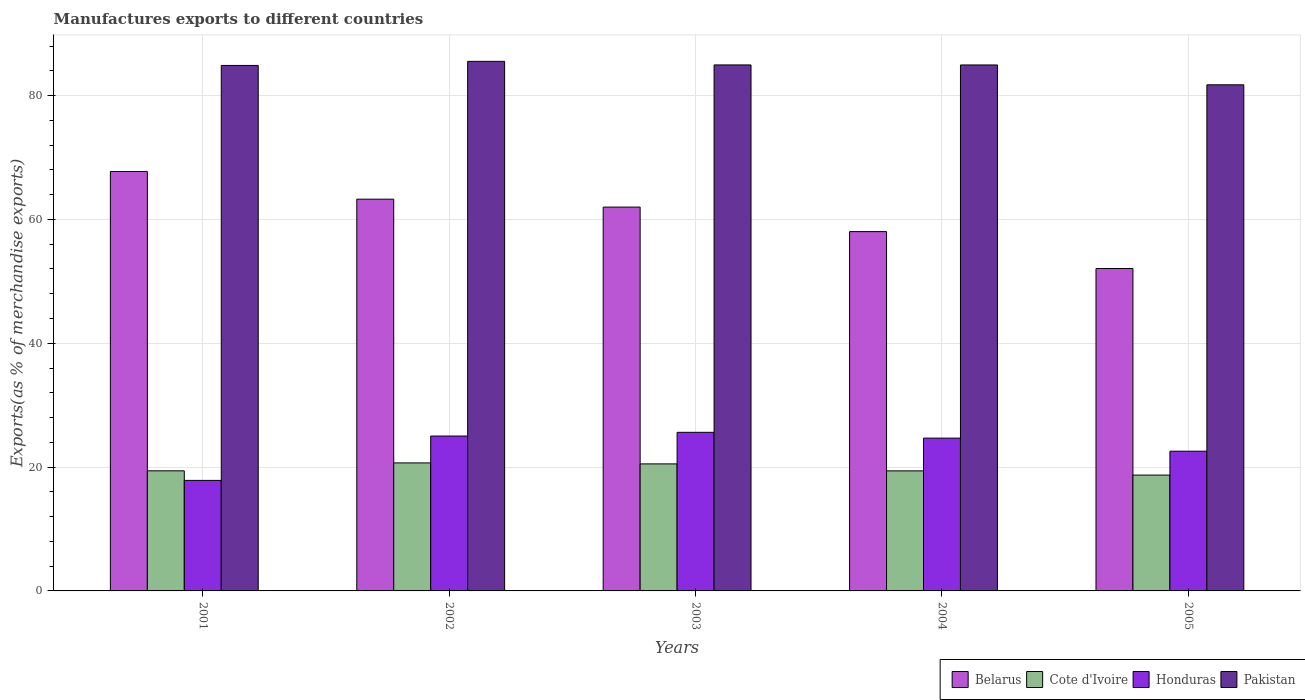Are the number of bars per tick equal to the number of legend labels?
Ensure brevity in your answer.  Yes. Are the number of bars on each tick of the X-axis equal?
Offer a terse response. Yes. How many bars are there on the 1st tick from the left?
Give a very brief answer. 4. How many bars are there on the 3rd tick from the right?
Keep it short and to the point. 4. What is the label of the 2nd group of bars from the left?
Your answer should be compact. 2002. In how many cases, is the number of bars for a given year not equal to the number of legend labels?
Your answer should be compact. 0. What is the percentage of exports to different countries in Cote d'Ivoire in 2004?
Give a very brief answer. 19.39. Across all years, what is the maximum percentage of exports to different countries in Pakistan?
Your answer should be compact. 85.54. Across all years, what is the minimum percentage of exports to different countries in Belarus?
Your response must be concise. 52.08. In which year was the percentage of exports to different countries in Cote d'Ivoire minimum?
Ensure brevity in your answer.  2005. What is the total percentage of exports to different countries in Cote d'Ivoire in the graph?
Your response must be concise. 98.69. What is the difference between the percentage of exports to different countries in Belarus in 2004 and that in 2005?
Your response must be concise. 5.96. What is the difference between the percentage of exports to different countries in Cote d'Ivoire in 2003 and the percentage of exports to different countries in Honduras in 2004?
Make the answer very short. -4.16. What is the average percentage of exports to different countries in Pakistan per year?
Your answer should be compact. 84.42. In the year 2005, what is the difference between the percentage of exports to different countries in Pakistan and percentage of exports to different countries in Belarus?
Your answer should be compact. 29.67. What is the ratio of the percentage of exports to different countries in Pakistan in 2002 to that in 2004?
Keep it short and to the point. 1.01. Is the percentage of exports to different countries in Pakistan in 2001 less than that in 2003?
Your answer should be compact. Yes. Is the difference between the percentage of exports to different countries in Pakistan in 2001 and 2004 greater than the difference between the percentage of exports to different countries in Belarus in 2001 and 2004?
Keep it short and to the point. No. What is the difference between the highest and the second highest percentage of exports to different countries in Belarus?
Provide a succinct answer. 4.47. What is the difference between the highest and the lowest percentage of exports to different countries in Pakistan?
Make the answer very short. 3.79. Is the sum of the percentage of exports to different countries in Belarus in 2001 and 2004 greater than the maximum percentage of exports to different countries in Pakistan across all years?
Ensure brevity in your answer.  Yes. Is it the case that in every year, the sum of the percentage of exports to different countries in Honduras and percentage of exports to different countries in Belarus is greater than the sum of percentage of exports to different countries in Cote d'Ivoire and percentage of exports to different countries in Pakistan?
Offer a very short reply. No. What does the 4th bar from the left in 2002 represents?
Provide a short and direct response. Pakistan. What does the 2nd bar from the right in 2001 represents?
Give a very brief answer. Honduras. How many bars are there?
Your answer should be compact. 20. Are all the bars in the graph horizontal?
Give a very brief answer. No. Where does the legend appear in the graph?
Give a very brief answer. Bottom right. How many legend labels are there?
Your answer should be very brief. 4. How are the legend labels stacked?
Offer a terse response. Horizontal. What is the title of the graph?
Provide a succinct answer. Manufactures exports to different countries. Does "Other small states" appear as one of the legend labels in the graph?
Give a very brief answer. No. What is the label or title of the Y-axis?
Give a very brief answer. Exports(as % of merchandise exports). What is the Exports(as % of merchandise exports) in Belarus in 2001?
Make the answer very short. 67.75. What is the Exports(as % of merchandise exports) of Cote d'Ivoire in 2001?
Offer a terse response. 19.4. What is the Exports(as % of merchandise exports) of Honduras in 2001?
Provide a short and direct response. 17.85. What is the Exports(as % of merchandise exports) in Pakistan in 2001?
Keep it short and to the point. 84.88. What is the Exports(as % of merchandise exports) of Belarus in 2002?
Provide a short and direct response. 63.28. What is the Exports(as % of merchandise exports) in Cote d'Ivoire in 2002?
Your response must be concise. 20.68. What is the Exports(as % of merchandise exports) in Honduras in 2002?
Offer a terse response. 25.02. What is the Exports(as % of merchandise exports) of Pakistan in 2002?
Ensure brevity in your answer.  85.54. What is the Exports(as % of merchandise exports) of Belarus in 2003?
Provide a succinct answer. 62. What is the Exports(as % of merchandise exports) of Cote d'Ivoire in 2003?
Offer a very short reply. 20.52. What is the Exports(as % of merchandise exports) of Honduras in 2003?
Provide a succinct answer. 25.62. What is the Exports(as % of merchandise exports) in Pakistan in 2003?
Your response must be concise. 84.96. What is the Exports(as % of merchandise exports) of Belarus in 2004?
Provide a succinct answer. 58.04. What is the Exports(as % of merchandise exports) in Cote d'Ivoire in 2004?
Keep it short and to the point. 19.39. What is the Exports(as % of merchandise exports) in Honduras in 2004?
Provide a short and direct response. 24.68. What is the Exports(as % of merchandise exports) of Pakistan in 2004?
Provide a succinct answer. 84.96. What is the Exports(as % of merchandise exports) of Belarus in 2005?
Ensure brevity in your answer.  52.08. What is the Exports(as % of merchandise exports) in Cote d'Ivoire in 2005?
Provide a succinct answer. 18.71. What is the Exports(as % of merchandise exports) of Honduras in 2005?
Offer a terse response. 22.57. What is the Exports(as % of merchandise exports) in Pakistan in 2005?
Provide a succinct answer. 81.75. Across all years, what is the maximum Exports(as % of merchandise exports) of Belarus?
Ensure brevity in your answer.  67.75. Across all years, what is the maximum Exports(as % of merchandise exports) in Cote d'Ivoire?
Your response must be concise. 20.68. Across all years, what is the maximum Exports(as % of merchandise exports) in Honduras?
Ensure brevity in your answer.  25.62. Across all years, what is the maximum Exports(as % of merchandise exports) in Pakistan?
Offer a terse response. 85.54. Across all years, what is the minimum Exports(as % of merchandise exports) of Belarus?
Provide a short and direct response. 52.08. Across all years, what is the minimum Exports(as % of merchandise exports) in Cote d'Ivoire?
Keep it short and to the point. 18.71. Across all years, what is the minimum Exports(as % of merchandise exports) in Honduras?
Provide a short and direct response. 17.85. Across all years, what is the minimum Exports(as % of merchandise exports) of Pakistan?
Offer a terse response. 81.75. What is the total Exports(as % of merchandise exports) in Belarus in the graph?
Offer a very short reply. 303.14. What is the total Exports(as % of merchandise exports) of Cote d'Ivoire in the graph?
Ensure brevity in your answer.  98.69. What is the total Exports(as % of merchandise exports) in Honduras in the graph?
Your answer should be compact. 115.74. What is the total Exports(as % of merchandise exports) in Pakistan in the graph?
Offer a very short reply. 422.08. What is the difference between the Exports(as % of merchandise exports) of Belarus in 2001 and that in 2002?
Your answer should be very brief. 4.47. What is the difference between the Exports(as % of merchandise exports) of Cote d'Ivoire in 2001 and that in 2002?
Make the answer very short. -1.28. What is the difference between the Exports(as % of merchandise exports) of Honduras in 2001 and that in 2002?
Make the answer very short. -7.17. What is the difference between the Exports(as % of merchandise exports) of Pakistan in 2001 and that in 2002?
Offer a terse response. -0.66. What is the difference between the Exports(as % of merchandise exports) of Belarus in 2001 and that in 2003?
Your answer should be very brief. 5.75. What is the difference between the Exports(as % of merchandise exports) in Cote d'Ivoire in 2001 and that in 2003?
Ensure brevity in your answer.  -1.12. What is the difference between the Exports(as % of merchandise exports) in Honduras in 2001 and that in 2003?
Make the answer very short. -7.77. What is the difference between the Exports(as % of merchandise exports) in Pakistan in 2001 and that in 2003?
Ensure brevity in your answer.  -0.08. What is the difference between the Exports(as % of merchandise exports) in Belarus in 2001 and that in 2004?
Give a very brief answer. 9.71. What is the difference between the Exports(as % of merchandise exports) of Cote d'Ivoire in 2001 and that in 2004?
Give a very brief answer. 0.01. What is the difference between the Exports(as % of merchandise exports) of Honduras in 2001 and that in 2004?
Provide a short and direct response. -6.83. What is the difference between the Exports(as % of merchandise exports) in Pakistan in 2001 and that in 2004?
Make the answer very short. -0.08. What is the difference between the Exports(as % of merchandise exports) in Belarus in 2001 and that in 2005?
Make the answer very short. 15.67. What is the difference between the Exports(as % of merchandise exports) in Cote d'Ivoire in 2001 and that in 2005?
Your answer should be very brief. 0.69. What is the difference between the Exports(as % of merchandise exports) in Honduras in 2001 and that in 2005?
Provide a succinct answer. -4.72. What is the difference between the Exports(as % of merchandise exports) of Pakistan in 2001 and that in 2005?
Your answer should be compact. 3.13. What is the difference between the Exports(as % of merchandise exports) in Belarus in 2002 and that in 2003?
Provide a succinct answer. 1.28. What is the difference between the Exports(as % of merchandise exports) in Cote d'Ivoire in 2002 and that in 2003?
Provide a short and direct response. 0.16. What is the difference between the Exports(as % of merchandise exports) of Honduras in 2002 and that in 2003?
Your answer should be very brief. -0.6. What is the difference between the Exports(as % of merchandise exports) in Pakistan in 2002 and that in 2003?
Make the answer very short. 0.58. What is the difference between the Exports(as % of merchandise exports) of Belarus in 2002 and that in 2004?
Provide a short and direct response. 5.24. What is the difference between the Exports(as % of merchandise exports) in Cote d'Ivoire in 2002 and that in 2004?
Give a very brief answer. 1.28. What is the difference between the Exports(as % of merchandise exports) in Honduras in 2002 and that in 2004?
Your answer should be very brief. 0.34. What is the difference between the Exports(as % of merchandise exports) in Pakistan in 2002 and that in 2004?
Ensure brevity in your answer.  0.58. What is the difference between the Exports(as % of merchandise exports) in Belarus in 2002 and that in 2005?
Your response must be concise. 11.2. What is the difference between the Exports(as % of merchandise exports) of Cote d'Ivoire in 2002 and that in 2005?
Offer a very short reply. 1.97. What is the difference between the Exports(as % of merchandise exports) of Honduras in 2002 and that in 2005?
Offer a terse response. 2.45. What is the difference between the Exports(as % of merchandise exports) of Pakistan in 2002 and that in 2005?
Keep it short and to the point. 3.79. What is the difference between the Exports(as % of merchandise exports) of Belarus in 2003 and that in 2004?
Offer a terse response. 3.96. What is the difference between the Exports(as % of merchandise exports) in Cote d'Ivoire in 2003 and that in 2004?
Provide a succinct answer. 1.13. What is the difference between the Exports(as % of merchandise exports) of Honduras in 2003 and that in 2004?
Keep it short and to the point. 0.94. What is the difference between the Exports(as % of merchandise exports) in Pakistan in 2003 and that in 2004?
Make the answer very short. 0. What is the difference between the Exports(as % of merchandise exports) in Belarus in 2003 and that in 2005?
Ensure brevity in your answer.  9.92. What is the difference between the Exports(as % of merchandise exports) of Cote d'Ivoire in 2003 and that in 2005?
Offer a terse response. 1.81. What is the difference between the Exports(as % of merchandise exports) of Honduras in 2003 and that in 2005?
Give a very brief answer. 3.05. What is the difference between the Exports(as % of merchandise exports) in Pakistan in 2003 and that in 2005?
Make the answer very short. 3.21. What is the difference between the Exports(as % of merchandise exports) of Belarus in 2004 and that in 2005?
Your answer should be very brief. 5.96. What is the difference between the Exports(as % of merchandise exports) of Cote d'Ivoire in 2004 and that in 2005?
Your answer should be compact. 0.68. What is the difference between the Exports(as % of merchandise exports) of Honduras in 2004 and that in 2005?
Give a very brief answer. 2.11. What is the difference between the Exports(as % of merchandise exports) in Pakistan in 2004 and that in 2005?
Offer a very short reply. 3.21. What is the difference between the Exports(as % of merchandise exports) of Belarus in 2001 and the Exports(as % of merchandise exports) of Cote d'Ivoire in 2002?
Provide a succinct answer. 47.07. What is the difference between the Exports(as % of merchandise exports) of Belarus in 2001 and the Exports(as % of merchandise exports) of Honduras in 2002?
Your answer should be very brief. 42.73. What is the difference between the Exports(as % of merchandise exports) of Belarus in 2001 and the Exports(as % of merchandise exports) of Pakistan in 2002?
Make the answer very short. -17.79. What is the difference between the Exports(as % of merchandise exports) of Cote d'Ivoire in 2001 and the Exports(as % of merchandise exports) of Honduras in 2002?
Your answer should be compact. -5.62. What is the difference between the Exports(as % of merchandise exports) of Cote d'Ivoire in 2001 and the Exports(as % of merchandise exports) of Pakistan in 2002?
Give a very brief answer. -66.14. What is the difference between the Exports(as % of merchandise exports) of Honduras in 2001 and the Exports(as % of merchandise exports) of Pakistan in 2002?
Ensure brevity in your answer.  -67.69. What is the difference between the Exports(as % of merchandise exports) of Belarus in 2001 and the Exports(as % of merchandise exports) of Cote d'Ivoire in 2003?
Your response must be concise. 47.23. What is the difference between the Exports(as % of merchandise exports) of Belarus in 2001 and the Exports(as % of merchandise exports) of Honduras in 2003?
Keep it short and to the point. 42.13. What is the difference between the Exports(as % of merchandise exports) in Belarus in 2001 and the Exports(as % of merchandise exports) in Pakistan in 2003?
Your response must be concise. -17.21. What is the difference between the Exports(as % of merchandise exports) of Cote d'Ivoire in 2001 and the Exports(as % of merchandise exports) of Honduras in 2003?
Your answer should be compact. -6.22. What is the difference between the Exports(as % of merchandise exports) in Cote d'Ivoire in 2001 and the Exports(as % of merchandise exports) in Pakistan in 2003?
Your answer should be compact. -65.56. What is the difference between the Exports(as % of merchandise exports) in Honduras in 2001 and the Exports(as % of merchandise exports) in Pakistan in 2003?
Make the answer very short. -67.11. What is the difference between the Exports(as % of merchandise exports) in Belarus in 2001 and the Exports(as % of merchandise exports) in Cote d'Ivoire in 2004?
Ensure brevity in your answer.  48.36. What is the difference between the Exports(as % of merchandise exports) in Belarus in 2001 and the Exports(as % of merchandise exports) in Honduras in 2004?
Offer a very short reply. 43.07. What is the difference between the Exports(as % of merchandise exports) of Belarus in 2001 and the Exports(as % of merchandise exports) of Pakistan in 2004?
Ensure brevity in your answer.  -17.21. What is the difference between the Exports(as % of merchandise exports) in Cote d'Ivoire in 2001 and the Exports(as % of merchandise exports) in Honduras in 2004?
Provide a succinct answer. -5.28. What is the difference between the Exports(as % of merchandise exports) in Cote d'Ivoire in 2001 and the Exports(as % of merchandise exports) in Pakistan in 2004?
Offer a very short reply. -65.56. What is the difference between the Exports(as % of merchandise exports) of Honduras in 2001 and the Exports(as % of merchandise exports) of Pakistan in 2004?
Your response must be concise. -67.1. What is the difference between the Exports(as % of merchandise exports) in Belarus in 2001 and the Exports(as % of merchandise exports) in Cote d'Ivoire in 2005?
Your answer should be compact. 49.04. What is the difference between the Exports(as % of merchandise exports) of Belarus in 2001 and the Exports(as % of merchandise exports) of Honduras in 2005?
Your answer should be very brief. 45.18. What is the difference between the Exports(as % of merchandise exports) in Belarus in 2001 and the Exports(as % of merchandise exports) in Pakistan in 2005?
Offer a terse response. -14. What is the difference between the Exports(as % of merchandise exports) in Cote d'Ivoire in 2001 and the Exports(as % of merchandise exports) in Honduras in 2005?
Offer a terse response. -3.17. What is the difference between the Exports(as % of merchandise exports) in Cote d'Ivoire in 2001 and the Exports(as % of merchandise exports) in Pakistan in 2005?
Offer a very short reply. -62.35. What is the difference between the Exports(as % of merchandise exports) of Honduras in 2001 and the Exports(as % of merchandise exports) of Pakistan in 2005?
Offer a terse response. -63.9. What is the difference between the Exports(as % of merchandise exports) in Belarus in 2002 and the Exports(as % of merchandise exports) in Cote d'Ivoire in 2003?
Provide a succinct answer. 42.76. What is the difference between the Exports(as % of merchandise exports) in Belarus in 2002 and the Exports(as % of merchandise exports) in Honduras in 2003?
Your answer should be compact. 37.66. What is the difference between the Exports(as % of merchandise exports) in Belarus in 2002 and the Exports(as % of merchandise exports) in Pakistan in 2003?
Offer a very short reply. -21.68. What is the difference between the Exports(as % of merchandise exports) of Cote d'Ivoire in 2002 and the Exports(as % of merchandise exports) of Honduras in 2003?
Your response must be concise. -4.94. What is the difference between the Exports(as % of merchandise exports) of Cote d'Ivoire in 2002 and the Exports(as % of merchandise exports) of Pakistan in 2003?
Provide a succinct answer. -64.28. What is the difference between the Exports(as % of merchandise exports) in Honduras in 2002 and the Exports(as % of merchandise exports) in Pakistan in 2003?
Your answer should be very brief. -59.94. What is the difference between the Exports(as % of merchandise exports) of Belarus in 2002 and the Exports(as % of merchandise exports) of Cote d'Ivoire in 2004?
Provide a succinct answer. 43.89. What is the difference between the Exports(as % of merchandise exports) of Belarus in 2002 and the Exports(as % of merchandise exports) of Honduras in 2004?
Give a very brief answer. 38.6. What is the difference between the Exports(as % of merchandise exports) of Belarus in 2002 and the Exports(as % of merchandise exports) of Pakistan in 2004?
Give a very brief answer. -21.68. What is the difference between the Exports(as % of merchandise exports) of Cote d'Ivoire in 2002 and the Exports(as % of merchandise exports) of Honduras in 2004?
Your answer should be very brief. -4.01. What is the difference between the Exports(as % of merchandise exports) of Cote d'Ivoire in 2002 and the Exports(as % of merchandise exports) of Pakistan in 2004?
Ensure brevity in your answer.  -64.28. What is the difference between the Exports(as % of merchandise exports) in Honduras in 2002 and the Exports(as % of merchandise exports) in Pakistan in 2004?
Offer a very short reply. -59.94. What is the difference between the Exports(as % of merchandise exports) of Belarus in 2002 and the Exports(as % of merchandise exports) of Cote d'Ivoire in 2005?
Offer a terse response. 44.57. What is the difference between the Exports(as % of merchandise exports) of Belarus in 2002 and the Exports(as % of merchandise exports) of Honduras in 2005?
Make the answer very short. 40.71. What is the difference between the Exports(as % of merchandise exports) of Belarus in 2002 and the Exports(as % of merchandise exports) of Pakistan in 2005?
Your answer should be compact. -18.47. What is the difference between the Exports(as % of merchandise exports) in Cote d'Ivoire in 2002 and the Exports(as % of merchandise exports) in Honduras in 2005?
Give a very brief answer. -1.89. What is the difference between the Exports(as % of merchandise exports) of Cote d'Ivoire in 2002 and the Exports(as % of merchandise exports) of Pakistan in 2005?
Your response must be concise. -61.07. What is the difference between the Exports(as % of merchandise exports) of Honduras in 2002 and the Exports(as % of merchandise exports) of Pakistan in 2005?
Ensure brevity in your answer.  -56.73. What is the difference between the Exports(as % of merchandise exports) in Belarus in 2003 and the Exports(as % of merchandise exports) in Cote d'Ivoire in 2004?
Provide a succinct answer. 42.61. What is the difference between the Exports(as % of merchandise exports) of Belarus in 2003 and the Exports(as % of merchandise exports) of Honduras in 2004?
Your answer should be compact. 37.32. What is the difference between the Exports(as % of merchandise exports) of Belarus in 2003 and the Exports(as % of merchandise exports) of Pakistan in 2004?
Provide a short and direct response. -22.96. What is the difference between the Exports(as % of merchandise exports) in Cote d'Ivoire in 2003 and the Exports(as % of merchandise exports) in Honduras in 2004?
Your answer should be very brief. -4.16. What is the difference between the Exports(as % of merchandise exports) of Cote d'Ivoire in 2003 and the Exports(as % of merchandise exports) of Pakistan in 2004?
Your answer should be compact. -64.44. What is the difference between the Exports(as % of merchandise exports) in Honduras in 2003 and the Exports(as % of merchandise exports) in Pakistan in 2004?
Make the answer very short. -59.34. What is the difference between the Exports(as % of merchandise exports) in Belarus in 2003 and the Exports(as % of merchandise exports) in Cote d'Ivoire in 2005?
Keep it short and to the point. 43.29. What is the difference between the Exports(as % of merchandise exports) in Belarus in 2003 and the Exports(as % of merchandise exports) in Honduras in 2005?
Provide a short and direct response. 39.43. What is the difference between the Exports(as % of merchandise exports) of Belarus in 2003 and the Exports(as % of merchandise exports) of Pakistan in 2005?
Offer a terse response. -19.75. What is the difference between the Exports(as % of merchandise exports) in Cote d'Ivoire in 2003 and the Exports(as % of merchandise exports) in Honduras in 2005?
Ensure brevity in your answer.  -2.05. What is the difference between the Exports(as % of merchandise exports) of Cote d'Ivoire in 2003 and the Exports(as % of merchandise exports) of Pakistan in 2005?
Your answer should be compact. -61.23. What is the difference between the Exports(as % of merchandise exports) of Honduras in 2003 and the Exports(as % of merchandise exports) of Pakistan in 2005?
Offer a very short reply. -56.13. What is the difference between the Exports(as % of merchandise exports) of Belarus in 2004 and the Exports(as % of merchandise exports) of Cote d'Ivoire in 2005?
Keep it short and to the point. 39.33. What is the difference between the Exports(as % of merchandise exports) in Belarus in 2004 and the Exports(as % of merchandise exports) in Honduras in 2005?
Provide a succinct answer. 35.47. What is the difference between the Exports(as % of merchandise exports) in Belarus in 2004 and the Exports(as % of merchandise exports) in Pakistan in 2005?
Your answer should be very brief. -23.71. What is the difference between the Exports(as % of merchandise exports) in Cote d'Ivoire in 2004 and the Exports(as % of merchandise exports) in Honduras in 2005?
Ensure brevity in your answer.  -3.18. What is the difference between the Exports(as % of merchandise exports) of Cote d'Ivoire in 2004 and the Exports(as % of merchandise exports) of Pakistan in 2005?
Offer a terse response. -62.36. What is the difference between the Exports(as % of merchandise exports) of Honduras in 2004 and the Exports(as % of merchandise exports) of Pakistan in 2005?
Make the answer very short. -57.07. What is the average Exports(as % of merchandise exports) in Belarus per year?
Offer a very short reply. 60.63. What is the average Exports(as % of merchandise exports) in Cote d'Ivoire per year?
Provide a succinct answer. 19.74. What is the average Exports(as % of merchandise exports) in Honduras per year?
Provide a succinct answer. 23.15. What is the average Exports(as % of merchandise exports) of Pakistan per year?
Offer a terse response. 84.42. In the year 2001, what is the difference between the Exports(as % of merchandise exports) in Belarus and Exports(as % of merchandise exports) in Cote d'Ivoire?
Your answer should be compact. 48.35. In the year 2001, what is the difference between the Exports(as % of merchandise exports) of Belarus and Exports(as % of merchandise exports) of Honduras?
Ensure brevity in your answer.  49.9. In the year 2001, what is the difference between the Exports(as % of merchandise exports) in Belarus and Exports(as % of merchandise exports) in Pakistan?
Keep it short and to the point. -17.13. In the year 2001, what is the difference between the Exports(as % of merchandise exports) of Cote d'Ivoire and Exports(as % of merchandise exports) of Honduras?
Your answer should be very brief. 1.55. In the year 2001, what is the difference between the Exports(as % of merchandise exports) of Cote d'Ivoire and Exports(as % of merchandise exports) of Pakistan?
Make the answer very short. -65.48. In the year 2001, what is the difference between the Exports(as % of merchandise exports) in Honduras and Exports(as % of merchandise exports) in Pakistan?
Offer a terse response. -67.03. In the year 2002, what is the difference between the Exports(as % of merchandise exports) of Belarus and Exports(as % of merchandise exports) of Cote d'Ivoire?
Make the answer very short. 42.6. In the year 2002, what is the difference between the Exports(as % of merchandise exports) of Belarus and Exports(as % of merchandise exports) of Honduras?
Your answer should be compact. 38.26. In the year 2002, what is the difference between the Exports(as % of merchandise exports) of Belarus and Exports(as % of merchandise exports) of Pakistan?
Provide a short and direct response. -22.26. In the year 2002, what is the difference between the Exports(as % of merchandise exports) of Cote d'Ivoire and Exports(as % of merchandise exports) of Honduras?
Your answer should be very brief. -4.34. In the year 2002, what is the difference between the Exports(as % of merchandise exports) of Cote d'Ivoire and Exports(as % of merchandise exports) of Pakistan?
Provide a short and direct response. -64.86. In the year 2002, what is the difference between the Exports(as % of merchandise exports) of Honduras and Exports(as % of merchandise exports) of Pakistan?
Make the answer very short. -60.52. In the year 2003, what is the difference between the Exports(as % of merchandise exports) in Belarus and Exports(as % of merchandise exports) in Cote d'Ivoire?
Offer a very short reply. 41.48. In the year 2003, what is the difference between the Exports(as % of merchandise exports) in Belarus and Exports(as % of merchandise exports) in Honduras?
Provide a short and direct response. 36.38. In the year 2003, what is the difference between the Exports(as % of merchandise exports) of Belarus and Exports(as % of merchandise exports) of Pakistan?
Give a very brief answer. -22.96. In the year 2003, what is the difference between the Exports(as % of merchandise exports) of Cote d'Ivoire and Exports(as % of merchandise exports) of Honduras?
Provide a short and direct response. -5.1. In the year 2003, what is the difference between the Exports(as % of merchandise exports) in Cote d'Ivoire and Exports(as % of merchandise exports) in Pakistan?
Offer a very short reply. -64.44. In the year 2003, what is the difference between the Exports(as % of merchandise exports) of Honduras and Exports(as % of merchandise exports) of Pakistan?
Provide a succinct answer. -59.34. In the year 2004, what is the difference between the Exports(as % of merchandise exports) of Belarus and Exports(as % of merchandise exports) of Cote d'Ivoire?
Your answer should be very brief. 38.65. In the year 2004, what is the difference between the Exports(as % of merchandise exports) in Belarus and Exports(as % of merchandise exports) in Honduras?
Provide a succinct answer. 33.36. In the year 2004, what is the difference between the Exports(as % of merchandise exports) in Belarus and Exports(as % of merchandise exports) in Pakistan?
Make the answer very short. -26.92. In the year 2004, what is the difference between the Exports(as % of merchandise exports) of Cote d'Ivoire and Exports(as % of merchandise exports) of Honduras?
Provide a short and direct response. -5.29. In the year 2004, what is the difference between the Exports(as % of merchandise exports) of Cote d'Ivoire and Exports(as % of merchandise exports) of Pakistan?
Provide a short and direct response. -65.56. In the year 2004, what is the difference between the Exports(as % of merchandise exports) in Honduras and Exports(as % of merchandise exports) in Pakistan?
Your answer should be compact. -60.27. In the year 2005, what is the difference between the Exports(as % of merchandise exports) of Belarus and Exports(as % of merchandise exports) of Cote d'Ivoire?
Ensure brevity in your answer.  33.37. In the year 2005, what is the difference between the Exports(as % of merchandise exports) in Belarus and Exports(as % of merchandise exports) in Honduras?
Your answer should be very brief. 29.51. In the year 2005, what is the difference between the Exports(as % of merchandise exports) of Belarus and Exports(as % of merchandise exports) of Pakistan?
Keep it short and to the point. -29.67. In the year 2005, what is the difference between the Exports(as % of merchandise exports) in Cote d'Ivoire and Exports(as % of merchandise exports) in Honduras?
Your response must be concise. -3.86. In the year 2005, what is the difference between the Exports(as % of merchandise exports) of Cote d'Ivoire and Exports(as % of merchandise exports) of Pakistan?
Your answer should be compact. -63.04. In the year 2005, what is the difference between the Exports(as % of merchandise exports) of Honduras and Exports(as % of merchandise exports) of Pakistan?
Give a very brief answer. -59.18. What is the ratio of the Exports(as % of merchandise exports) in Belarus in 2001 to that in 2002?
Your response must be concise. 1.07. What is the ratio of the Exports(as % of merchandise exports) in Cote d'Ivoire in 2001 to that in 2002?
Give a very brief answer. 0.94. What is the ratio of the Exports(as % of merchandise exports) of Honduras in 2001 to that in 2002?
Your answer should be compact. 0.71. What is the ratio of the Exports(as % of merchandise exports) in Belarus in 2001 to that in 2003?
Your response must be concise. 1.09. What is the ratio of the Exports(as % of merchandise exports) in Cote d'Ivoire in 2001 to that in 2003?
Make the answer very short. 0.95. What is the ratio of the Exports(as % of merchandise exports) in Honduras in 2001 to that in 2003?
Ensure brevity in your answer.  0.7. What is the ratio of the Exports(as % of merchandise exports) of Belarus in 2001 to that in 2004?
Offer a very short reply. 1.17. What is the ratio of the Exports(as % of merchandise exports) of Cote d'Ivoire in 2001 to that in 2004?
Provide a succinct answer. 1. What is the ratio of the Exports(as % of merchandise exports) of Honduras in 2001 to that in 2004?
Offer a terse response. 0.72. What is the ratio of the Exports(as % of merchandise exports) in Pakistan in 2001 to that in 2004?
Offer a very short reply. 1. What is the ratio of the Exports(as % of merchandise exports) of Belarus in 2001 to that in 2005?
Offer a terse response. 1.3. What is the ratio of the Exports(as % of merchandise exports) of Cote d'Ivoire in 2001 to that in 2005?
Your answer should be very brief. 1.04. What is the ratio of the Exports(as % of merchandise exports) of Honduras in 2001 to that in 2005?
Your answer should be very brief. 0.79. What is the ratio of the Exports(as % of merchandise exports) in Pakistan in 2001 to that in 2005?
Offer a very short reply. 1.04. What is the ratio of the Exports(as % of merchandise exports) in Belarus in 2002 to that in 2003?
Provide a short and direct response. 1.02. What is the ratio of the Exports(as % of merchandise exports) in Cote d'Ivoire in 2002 to that in 2003?
Offer a very short reply. 1.01. What is the ratio of the Exports(as % of merchandise exports) in Honduras in 2002 to that in 2003?
Offer a terse response. 0.98. What is the ratio of the Exports(as % of merchandise exports) in Pakistan in 2002 to that in 2003?
Keep it short and to the point. 1.01. What is the ratio of the Exports(as % of merchandise exports) in Belarus in 2002 to that in 2004?
Provide a short and direct response. 1.09. What is the ratio of the Exports(as % of merchandise exports) in Cote d'Ivoire in 2002 to that in 2004?
Your response must be concise. 1.07. What is the ratio of the Exports(as % of merchandise exports) of Honduras in 2002 to that in 2004?
Provide a succinct answer. 1.01. What is the ratio of the Exports(as % of merchandise exports) in Pakistan in 2002 to that in 2004?
Provide a short and direct response. 1.01. What is the ratio of the Exports(as % of merchandise exports) in Belarus in 2002 to that in 2005?
Provide a short and direct response. 1.22. What is the ratio of the Exports(as % of merchandise exports) of Cote d'Ivoire in 2002 to that in 2005?
Your answer should be very brief. 1.1. What is the ratio of the Exports(as % of merchandise exports) in Honduras in 2002 to that in 2005?
Your response must be concise. 1.11. What is the ratio of the Exports(as % of merchandise exports) of Pakistan in 2002 to that in 2005?
Offer a terse response. 1.05. What is the ratio of the Exports(as % of merchandise exports) of Belarus in 2003 to that in 2004?
Provide a succinct answer. 1.07. What is the ratio of the Exports(as % of merchandise exports) of Cote d'Ivoire in 2003 to that in 2004?
Provide a succinct answer. 1.06. What is the ratio of the Exports(as % of merchandise exports) of Honduras in 2003 to that in 2004?
Ensure brevity in your answer.  1.04. What is the ratio of the Exports(as % of merchandise exports) of Belarus in 2003 to that in 2005?
Ensure brevity in your answer.  1.19. What is the ratio of the Exports(as % of merchandise exports) in Cote d'Ivoire in 2003 to that in 2005?
Offer a very short reply. 1.1. What is the ratio of the Exports(as % of merchandise exports) of Honduras in 2003 to that in 2005?
Provide a succinct answer. 1.14. What is the ratio of the Exports(as % of merchandise exports) in Pakistan in 2003 to that in 2005?
Ensure brevity in your answer.  1.04. What is the ratio of the Exports(as % of merchandise exports) of Belarus in 2004 to that in 2005?
Your answer should be compact. 1.11. What is the ratio of the Exports(as % of merchandise exports) in Cote d'Ivoire in 2004 to that in 2005?
Offer a terse response. 1.04. What is the ratio of the Exports(as % of merchandise exports) of Honduras in 2004 to that in 2005?
Your answer should be very brief. 1.09. What is the ratio of the Exports(as % of merchandise exports) in Pakistan in 2004 to that in 2005?
Ensure brevity in your answer.  1.04. What is the difference between the highest and the second highest Exports(as % of merchandise exports) of Belarus?
Your answer should be compact. 4.47. What is the difference between the highest and the second highest Exports(as % of merchandise exports) in Cote d'Ivoire?
Offer a terse response. 0.16. What is the difference between the highest and the second highest Exports(as % of merchandise exports) in Honduras?
Keep it short and to the point. 0.6. What is the difference between the highest and the second highest Exports(as % of merchandise exports) in Pakistan?
Offer a very short reply. 0.58. What is the difference between the highest and the lowest Exports(as % of merchandise exports) in Belarus?
Provide a succinct answer. 15.67. What is the difference between the highest and the lowest Exports(as % of merchandise exports) in Cote d'Ivoire?
Provide a short and direct response. 1.97. What is the difference between the highest and the lowest Exports(as % of merchandise exports) in Honduras?
Ensure brevity in your answer.  7.77. What is the difference between the highest and the lowest Exports(as % of merchandise exports) of Pakistan?
Your answer should be very brief. 3.79. 